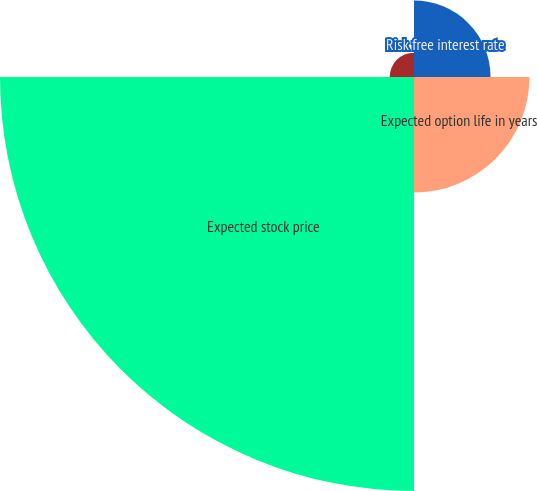Convert chart. <chart><loc_0><loc_0><loc_500><loc_500><pie_chart><fcel>Risk free interest rate<fcel>Expected option life in years<fcel>Expected stock price<fcel>Expected dividend yield<nl><fcel>12.14%<fcel>18.32%<fcel>65.67%<fcel>3.86%<nl></chart> 